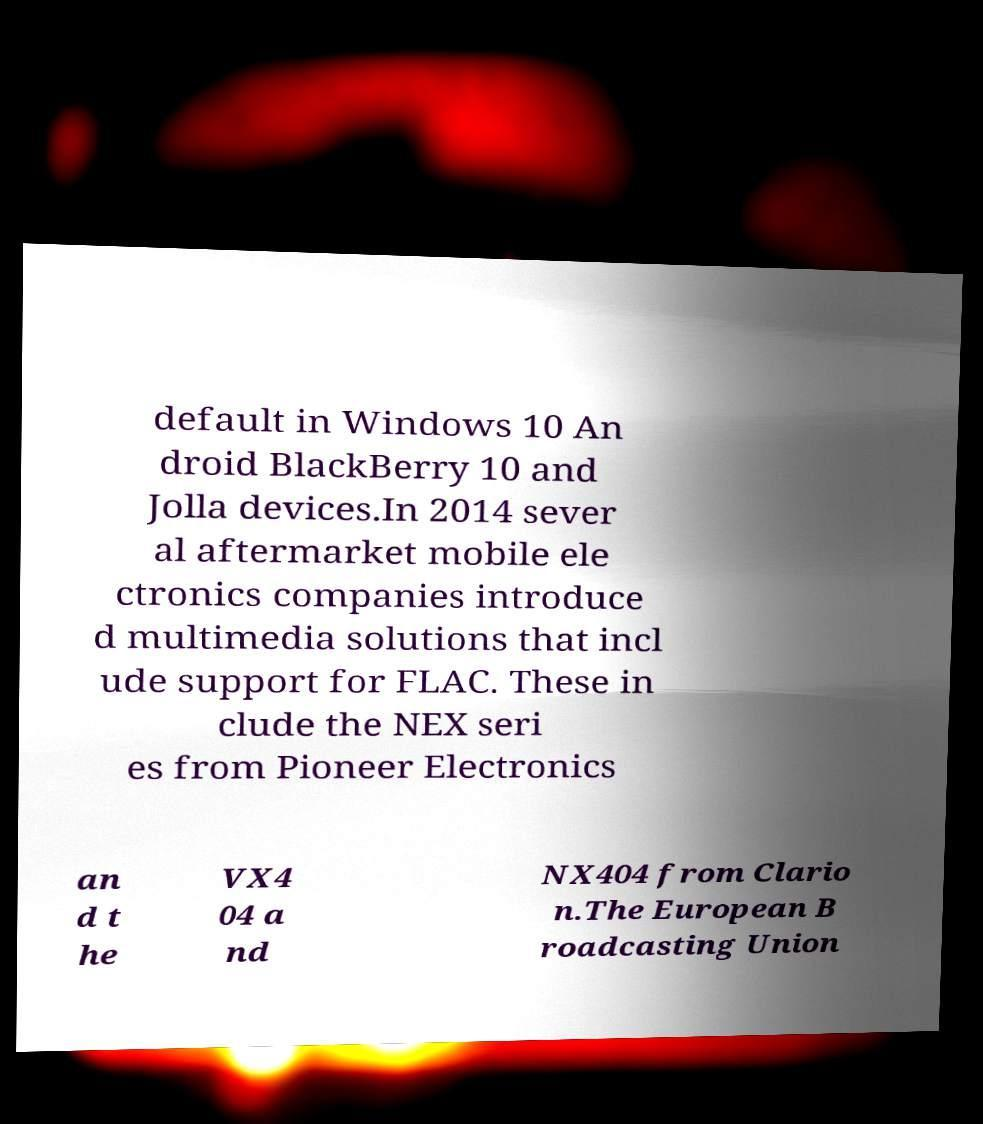Could you extract and type out the text from this image? default in Windows 10 An droid BlackBerry 10 and Jolla devices.In 2014 sever al aftermarket mobile ele ctronics companies introduce d multimedia solutions that incl ude support for FLAC. These in clude the NEX seri es from Pioneer Electronics an d t he VX4 04 a nd NX404 from Clario n.The European B roadcasting Union 